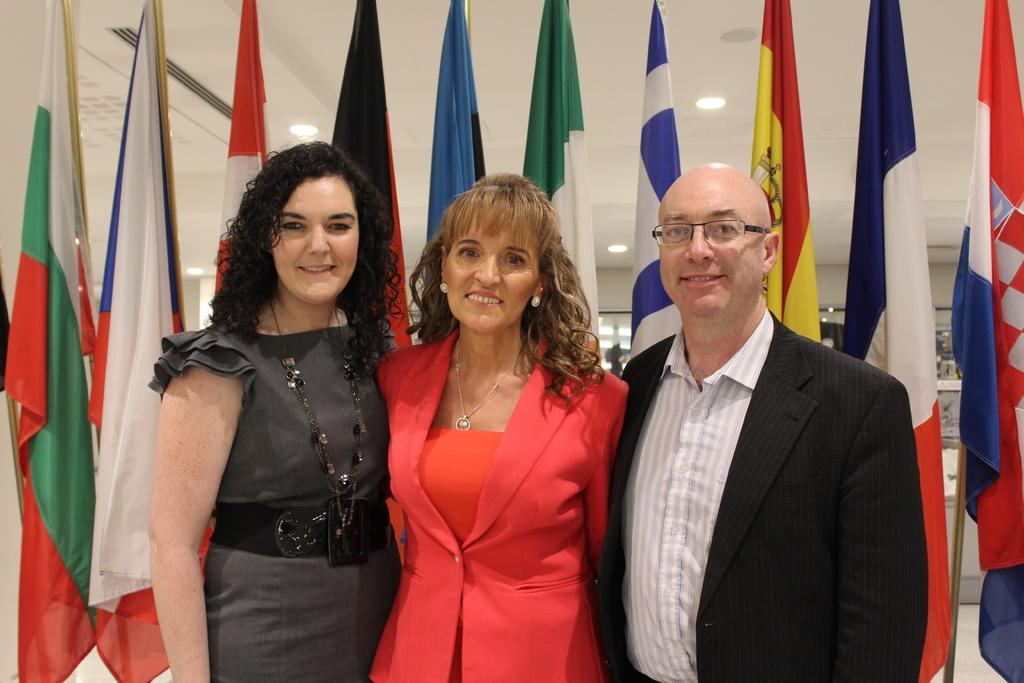How many people are present in the image? There are three people in the image: one man and two women. What are the people in the image doing? The people are standing in front, and they have smiles on their faces. What can be seen in the background of the image? There are flags and lights on the ceiling in the background of the image. Who is the creator of the land visible in the image? There is no land visible in the image, so it is not possible to determine who the creator might be. 